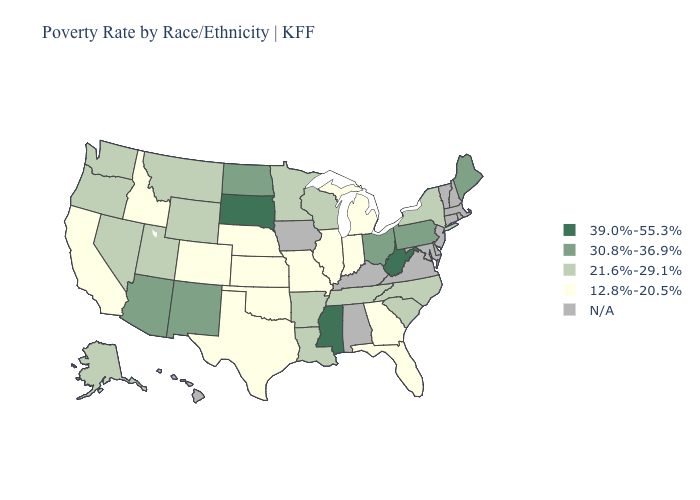Name the states that have a value in the range 39.0%-55.3%?
Answer briefly. Mississippi, South Dakota, West Virginia. Name the states that have a value in the range N/A?
Keep it brief. Alabama, Connecticut, Delaware, Hawaii, Iowa, Kentucky, Maryland, Massachusetts, New Hampshire, New Jersey, Rhode Island, Vermont, Virginia. Does the map have missing data?
Quick response, please. Yes. Name the states that have a value in the range 39.0%-55.3%?
Be succinct. Mississippi, South Dakota, West Virginia. Which states have the highest value in the USA?
Write a very short answer. Mississippi, South Dakota, West Virginia. Does North Carolina have the highest value in the USA?
Answer briefly. No. Which states have the lowest value in the South?
Quick response, please. Florida, Georgia, Oklahoma, Texas. What is the value of Alaska?
Quick response, please. 21.6%-29.1%. Does the first symbol in the legend represent the smallest category?
Answer briefly. No. What is the value of Idaho?
Quick response, please. 12.8%-20.5%. Does South Dakota have the highest value in the MidWest?
Short answer required. Yes. What is the value of New Hampshire?
Write a very short answer. N/A. What is the lowest value in states that border South Dakota?
Keep it brief. 12.8%-20.5%. Name the states that have a value in the range 39.0%-55.3%?
Keep it brief. Mississippi, South Dakota, West Virginia. 